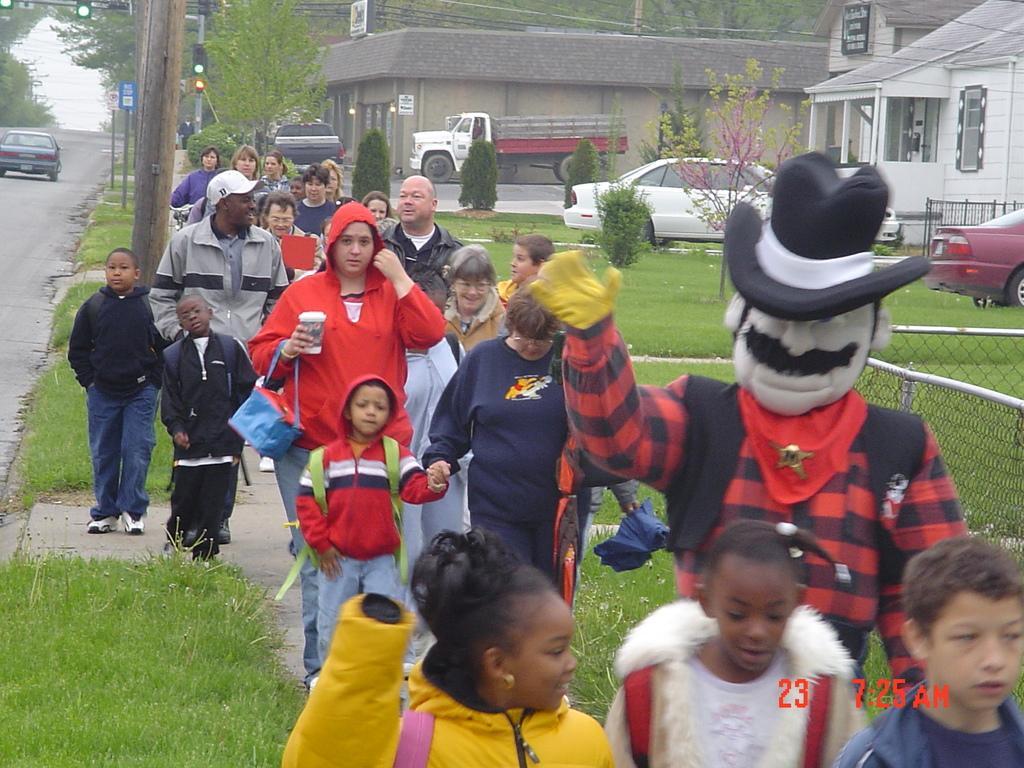Could you give a brief overview of what you see in this image? In the front of the image there are people, grass, mesh and objects. Among them one person wore a costume and few people are holding objects. In the background of the image there are buildings, vehicles, roads, signal lights, poles, boards, trees and objects.  